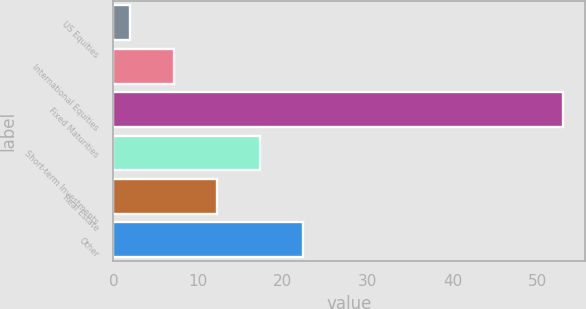Convert chart to OTSL. <chart><loc_0><loc_0><loc_500><loc_500><bar_chart><fcel>US Equities<fcel>International Equities<fcel>Fixed Maturities<fcel>Short-term Investments<fcel>Real Estate<fcel>Other<nl><fcel>2<fcel>7.1<fcel>53<fcel>17.3<fcel>12.2<fcel>22.4<nl></chart> 